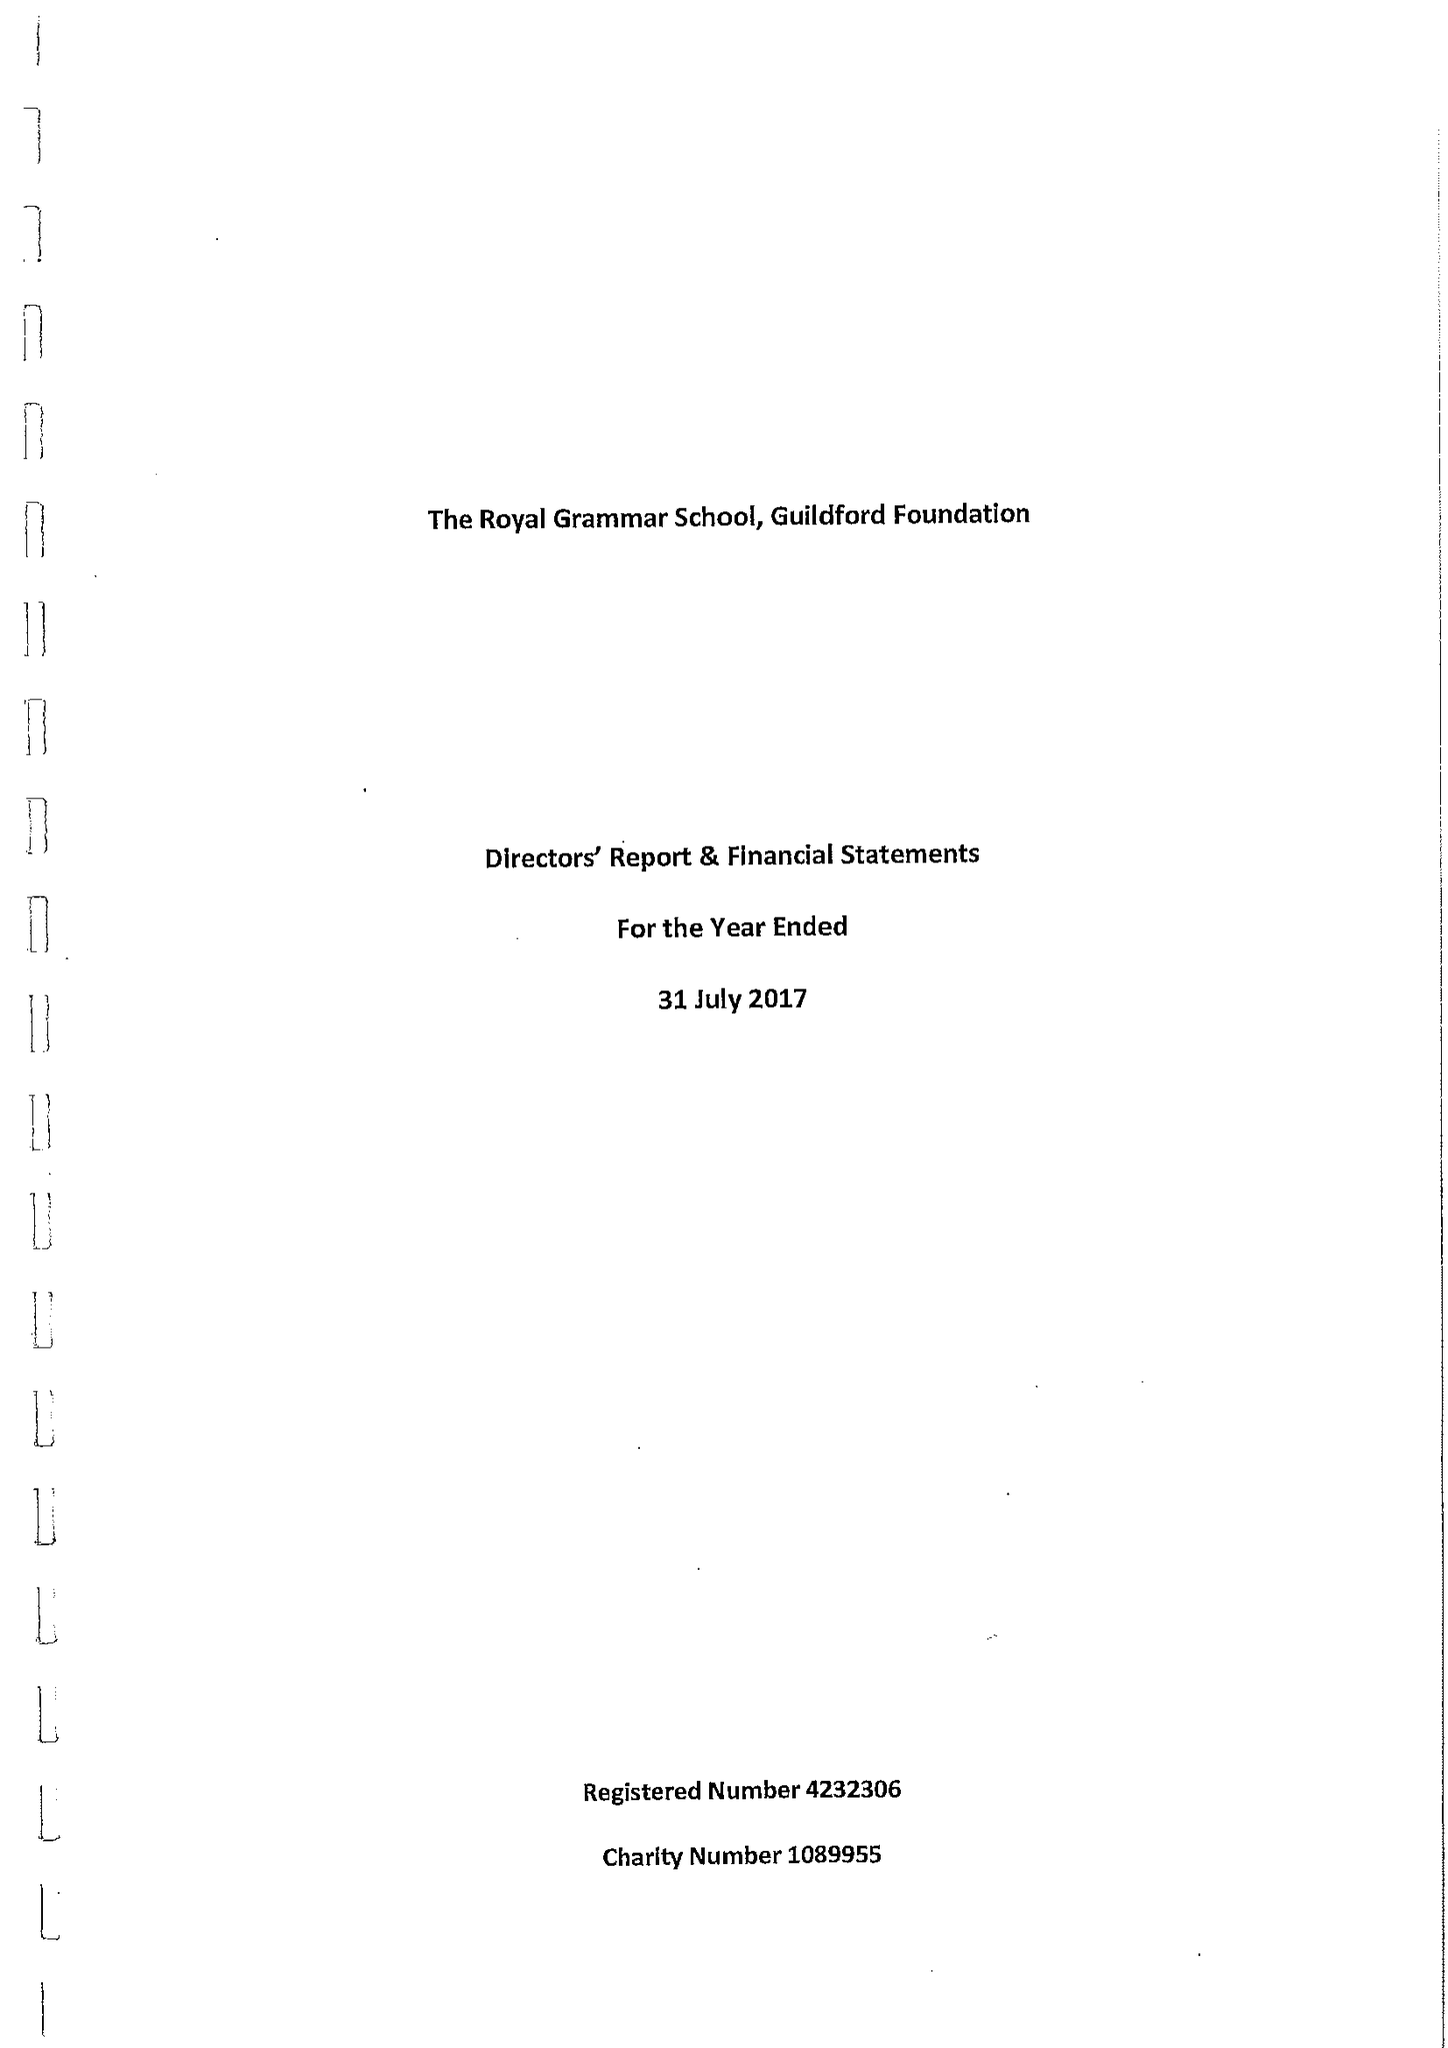What is the value for the charity_name?
Answer the question using a single word or phrase. The Royal Grammar School, Guildford Foundation 